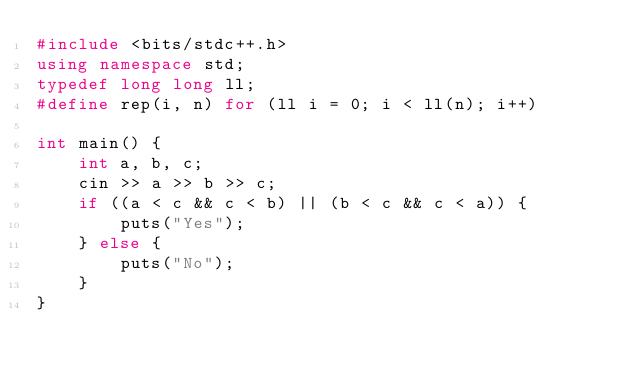Convert code to text. <code><loc_0><loc_0><loc_500><loc_500><_C++_>#include <bits/stdc++.h>
using namespace std;
typedef long long ll;
#define rep(i, n) for (ll i = 0; i < ll(n); i++)

int main() {
    int a, b, c;
    cin >> a >> b >> c;
    if ((a < c && c < b) || (b < c && c < a)) {
        puts("Yes");
    } else {
        puts("No");
    }
}
</code> 